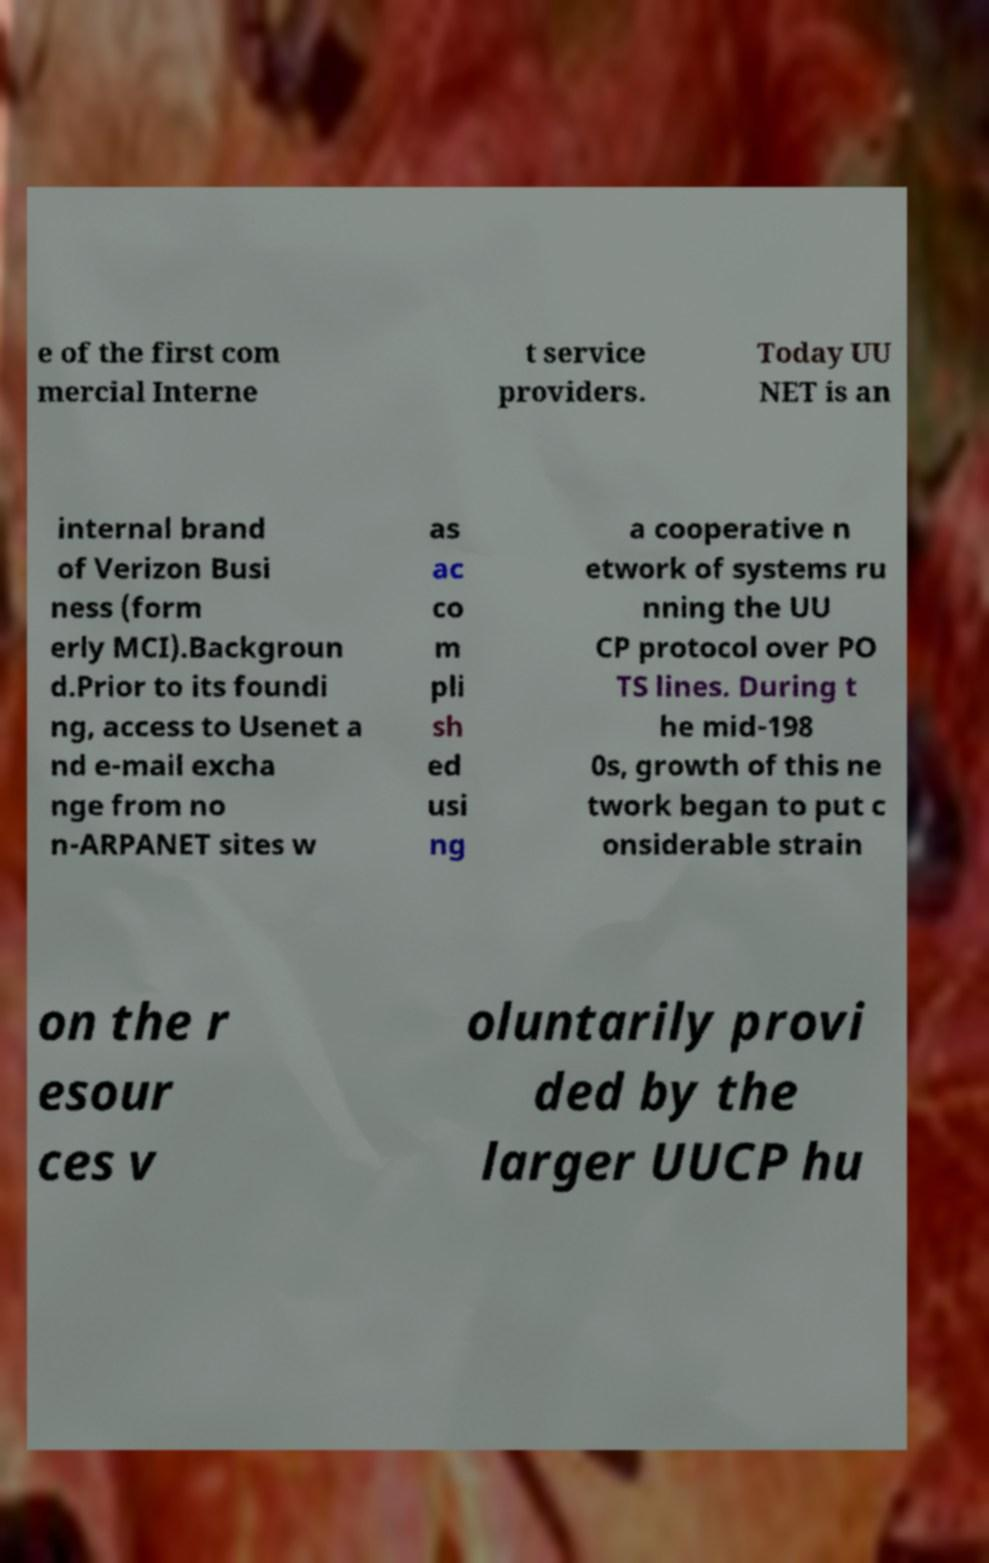Please identify and transcribe the text found in this image. e of the first com mercial Interne t service providers. Today UU NET is an internal brand of Verizon Busi ness (form erly MCI).Backgroun d.Prior to its foundi ng, access to Usenet a nd e-mail excha nge from no n-ARPANET sites w as ac co m pli sh ed usi ng a cooperative n etwork of systems ru nning the UU CP protocol over PO TS lines. During t he mid-198 0s, growth of this ne twork began to put c onsiderable strain on the r esour ces v oluntarily provi ded by the larger UUCP hu 